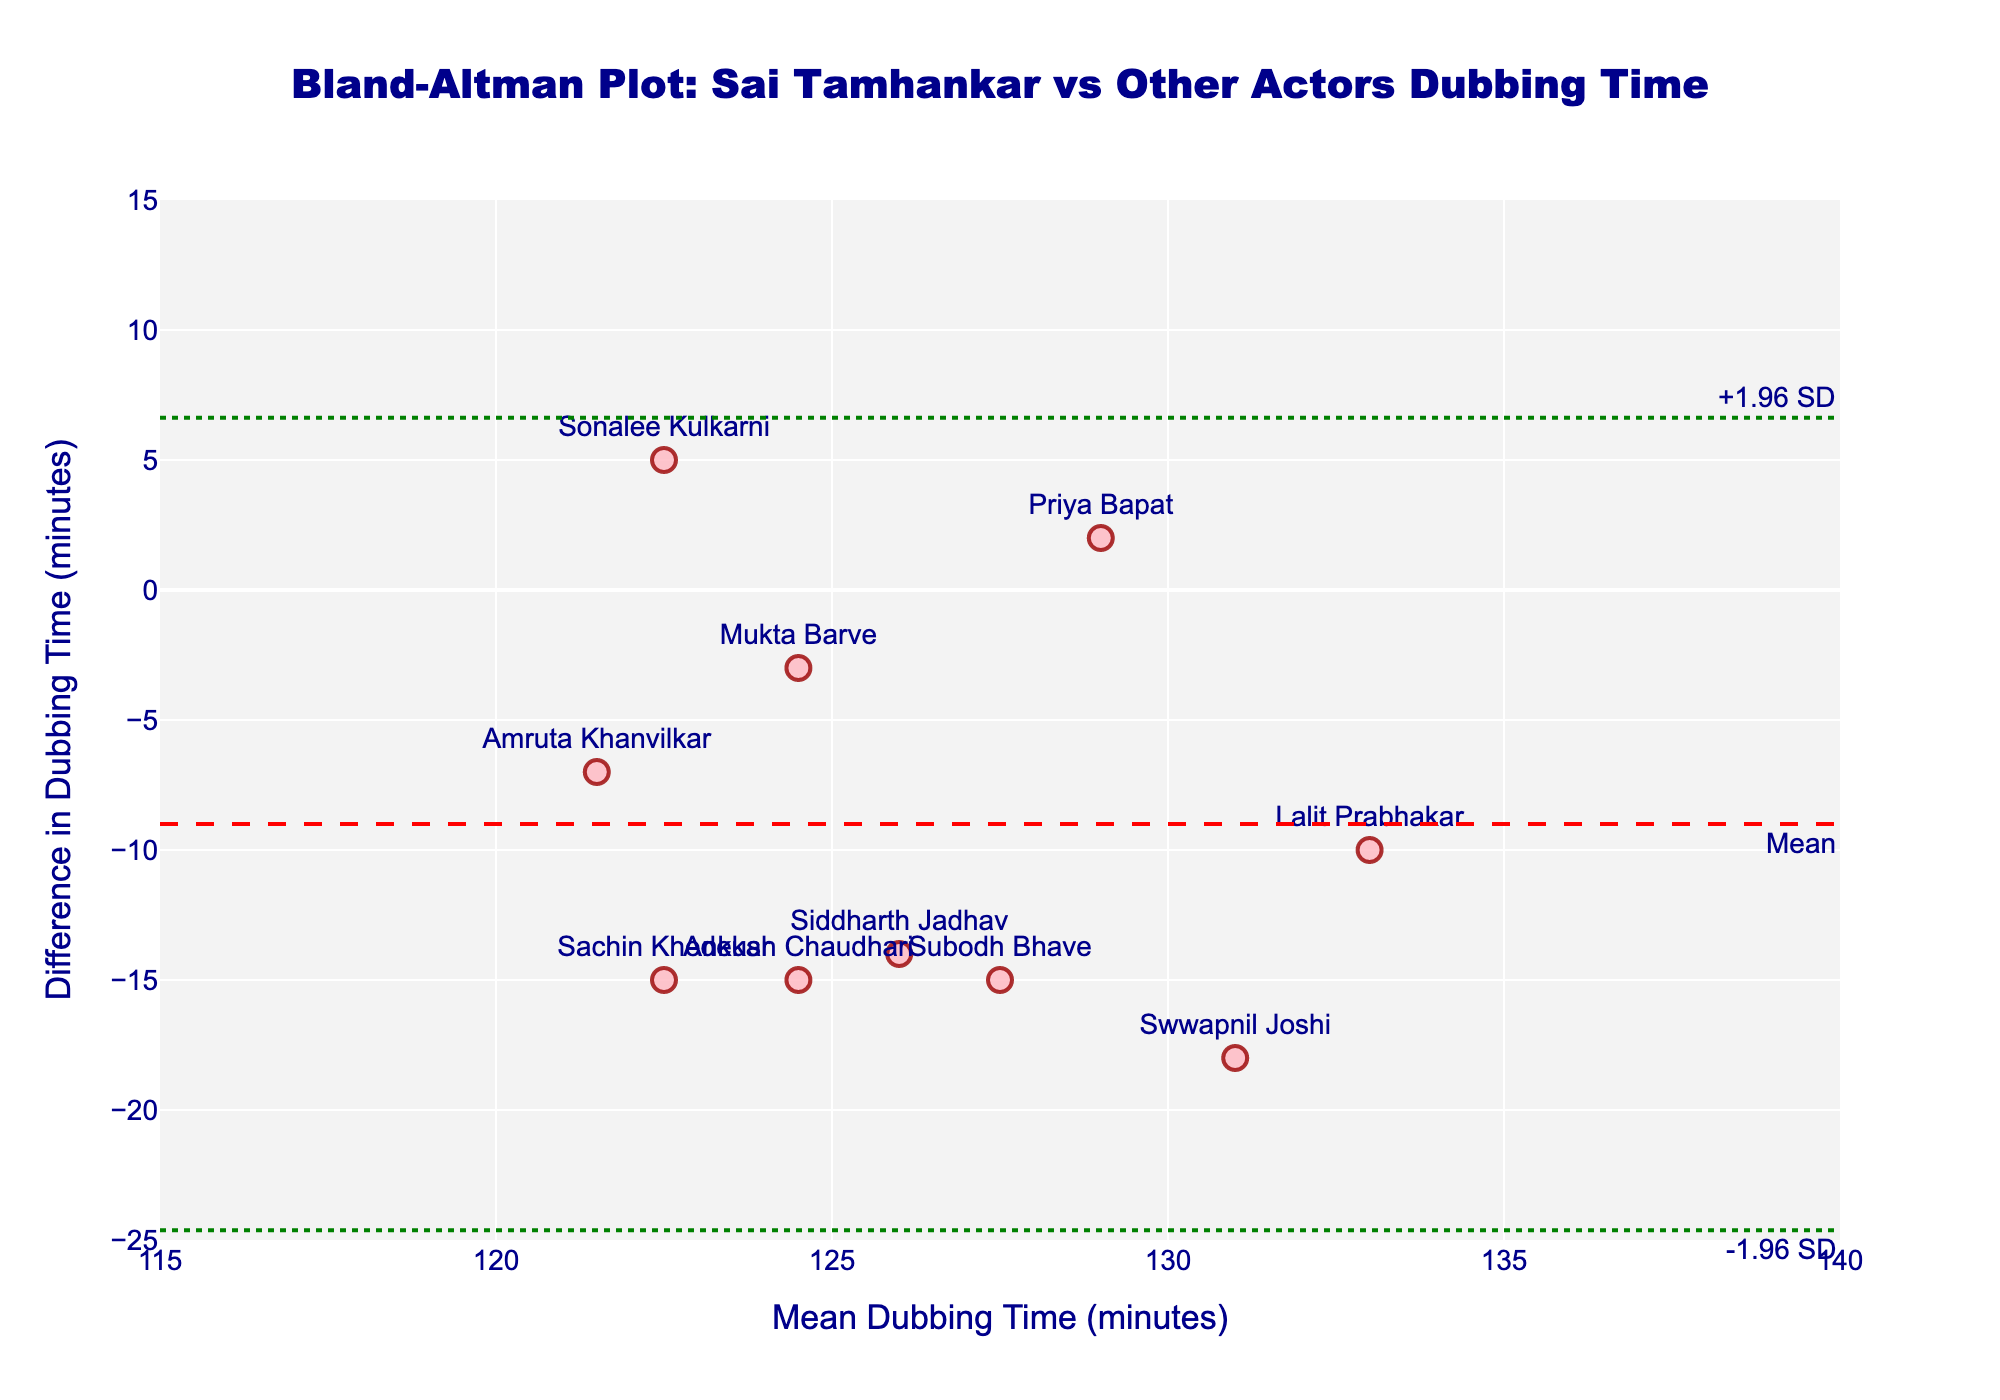What is the title of the plot? The title is prominently displayed at the top of the plot. It reads "Bland-Altman Plot: Sai Tamhankar vs Other Actors Dubbing Time."
Answer: Bland-Altman Plot: Sai Tamhankar vs Other Actors Dubbing Time What are the axes titles in the plot? The x-axis title is "Mean Dubbing Time (minutes)," and the y-axis title is "Difference in Dubbing Time (minutes)." These titles are shown along the respective axes.
Answer: Mean Dubbing Time (minutes) and Difference in Dubbing Time (minutes) How many data points are plotted on the graph? Each data point corresponds to one row in the provided data, representing the difference in dubbing time between Sai Tamhankar and another actor. There are 10 actors compared to Sai, so there are 10 points on the plot.
Answer: 10 What is the mean difference in dubbing time? The figure includes a dashed line annotated "Mean," representing the mean difference in dubbing time, which can be seen at approximately -9.
Answer: -9 What are the upper and lower limits of the difference in dubbing time? The plot includes dotted lines labeled "+1.96 SD" and "-1.96 SD" at the upper and lower limits, respectively. These limits are approximately +4 and -22.
Answer: +4 and -22 Which actor compared to Sai Tamhankar has the smallest difference in dubbing time? The actor closest to the x-axis (zero difference) has the smallest difference. Mukta Barve's marker is closest to zero compared to Sai.
Answer: Mukta Barve Which actor has the largest negative difference in dubbing time when compared to Sai Tamhankar? The largest negative difference is the point furthest down the y-axis. Swwapnil Joshi's marker is at -18, the most negative difference compared to Sai.
Answer: Swwapnil Joshi What is the range of mean dubbing times plotted on the x-axis? The x-axis spans from approximately 115 to 140 minutes, as indicated by the axis ticks.
Answer: 115 to 140 minutes How does the dubbing time for Sonalee Kulkarni compare to other actors? Sonalee Kulkarni’s data point is mentioned explicitly in the plot, showing a positive difference (above zero), meaning she requires less dubbing time than Sai Tamhankar among the comparisons shown.
Answer: Less than other actors compared to Sai 